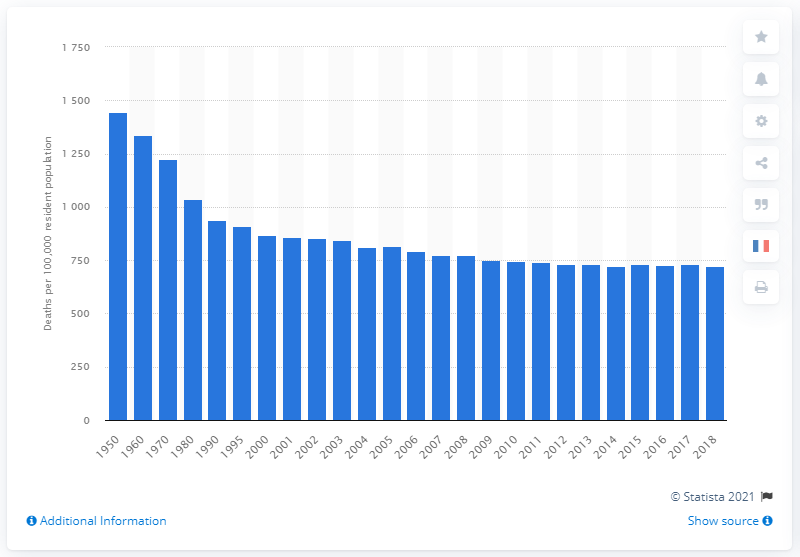Mention a couple of crucial points in this snapshot. The death rate in the United States between 1950 and 2018 was 723.6 deaths per 100,000 people. 